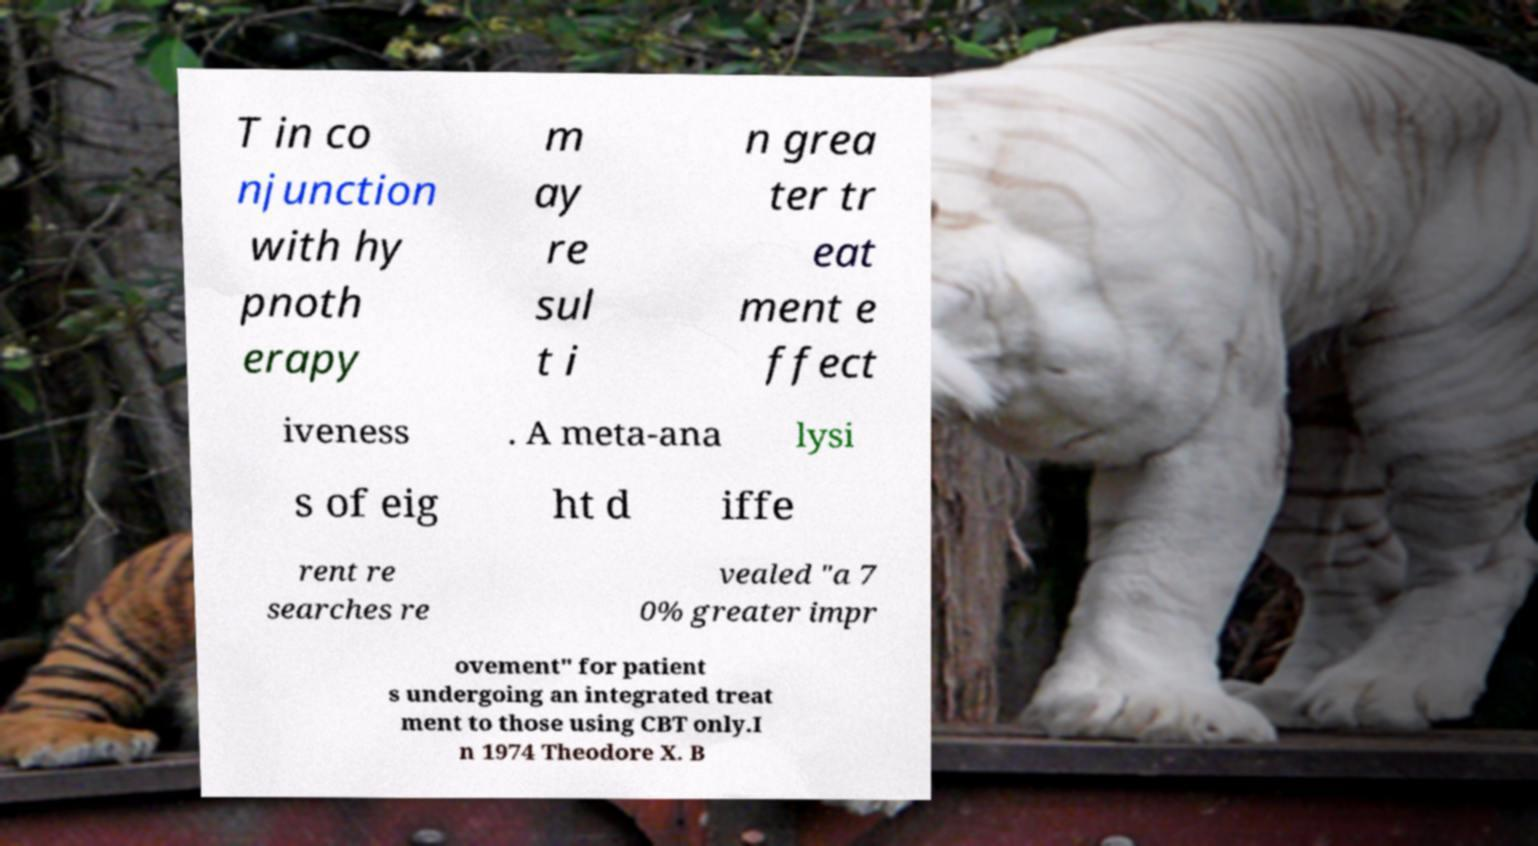There's text embedded in this image that I need extracted. Can you transcribe it verbatim? T in co njunction with hy pnoth erapy m ay re sul t i n grea ter tr eat ment e ffect iveness . A meta-ana lysi s of eig ht d iffe rent re searches re vealed "a 7 0% greater impr ovement" for patient s undergoing an integrated treat ment to those using CBT only.I n 1974 Theodore X. B 